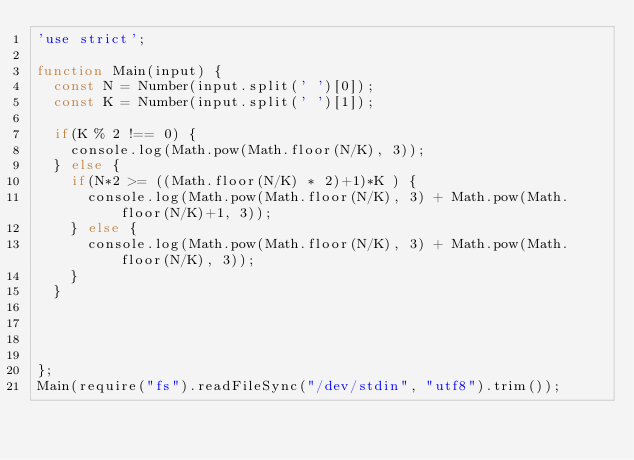<code> <loc_0><loc_0><loc_500><loc_500><_JavaScript_>'use strict';

function Main(input) {
  const N = Number(input.split(' ')[0]);
  const K = Number(input.split(' ')[1]);

  if(K % 2 !== 0) {
    console.log(Math.pow(Math.floor(N/K), 3));
  } else {
    if(N*2 >= ((Math.floor(N/K) * 2)+1)*K ) {
      console.log(Math.pow(Math.floor(N/K), 3) + Math.pow(Math.floor(N/K)+1, 3));
    } else {
      console.log(Math.pow(Math.floor(N/K), 3) + Math.pow(Math.floor(N/K), 3));
    }
  }




};
Main(require("fs").readFileSync("/dev/stdin", "utf8").trim());</code> 